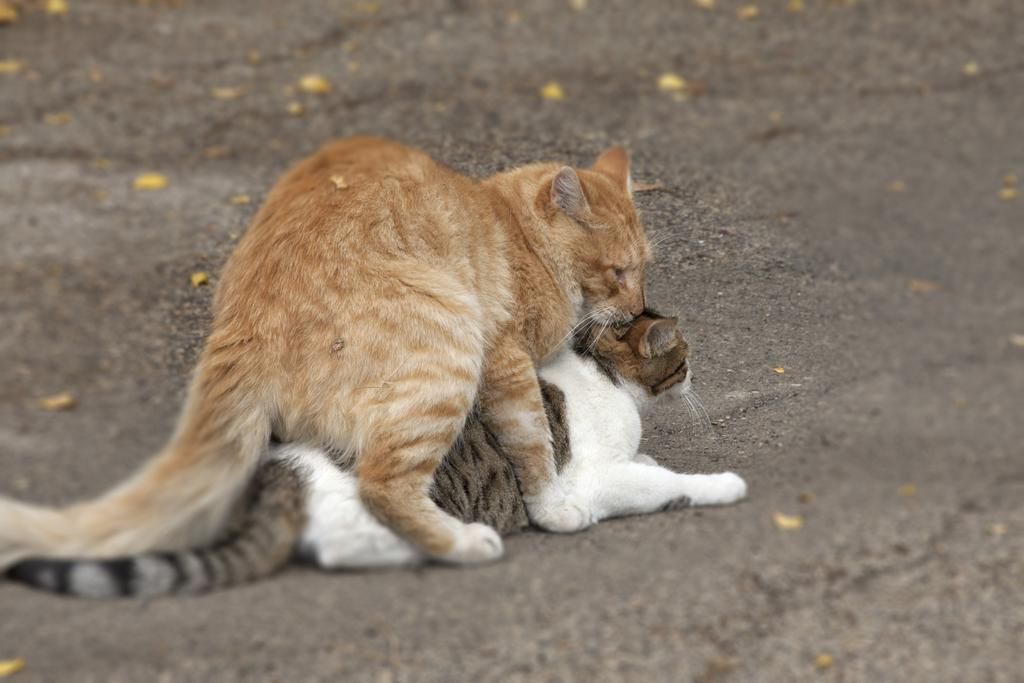What animals are present in the image? There are two cats in the image. Where are the cats located in the image? The cats are in the center of the image. Can you describe the positioning of the cats in relation to each other? One cat is above the other. What type of minister is depicted in the image? There is no minister present in the image; it features two cats. What role does the wire play in the image? There is no wire present in the image. What type of crime is being committed in the image? There is no crime being depicted in the image; it features two cats. 